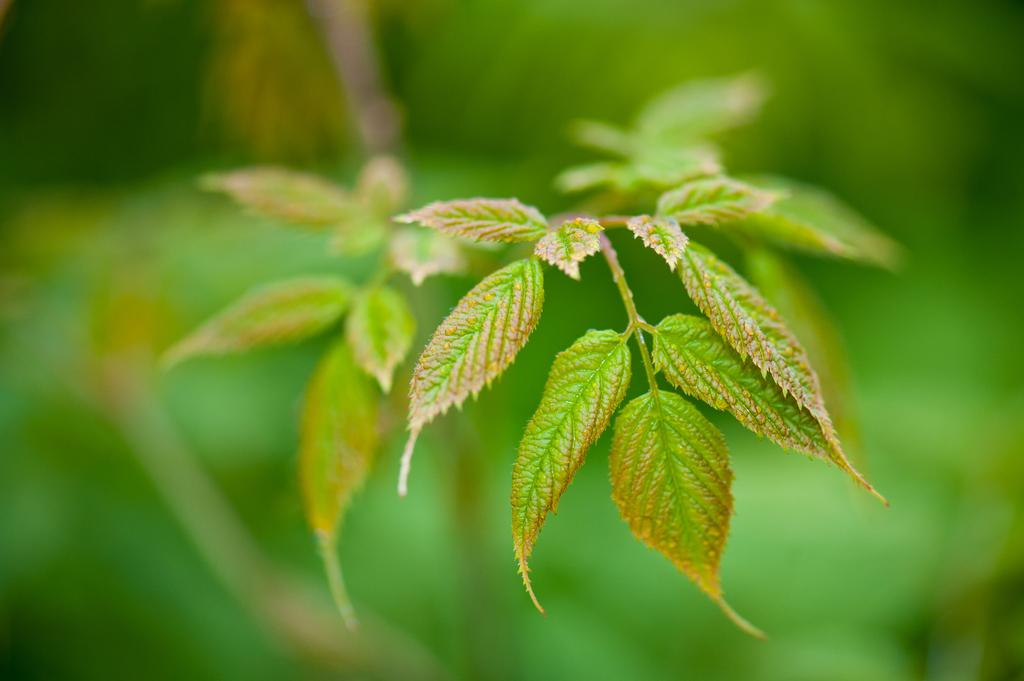What is the main subject of the image? The main subject of the image is a plant. What color are the leaves of the plant? The plant has green leaves. Can you describe the background of the image? The background of the image is blurry. What flavor of ice cream does the girl in the image prefer? There is no girl present in the image, and therefore no preference for ice cream flavor can be determined. 